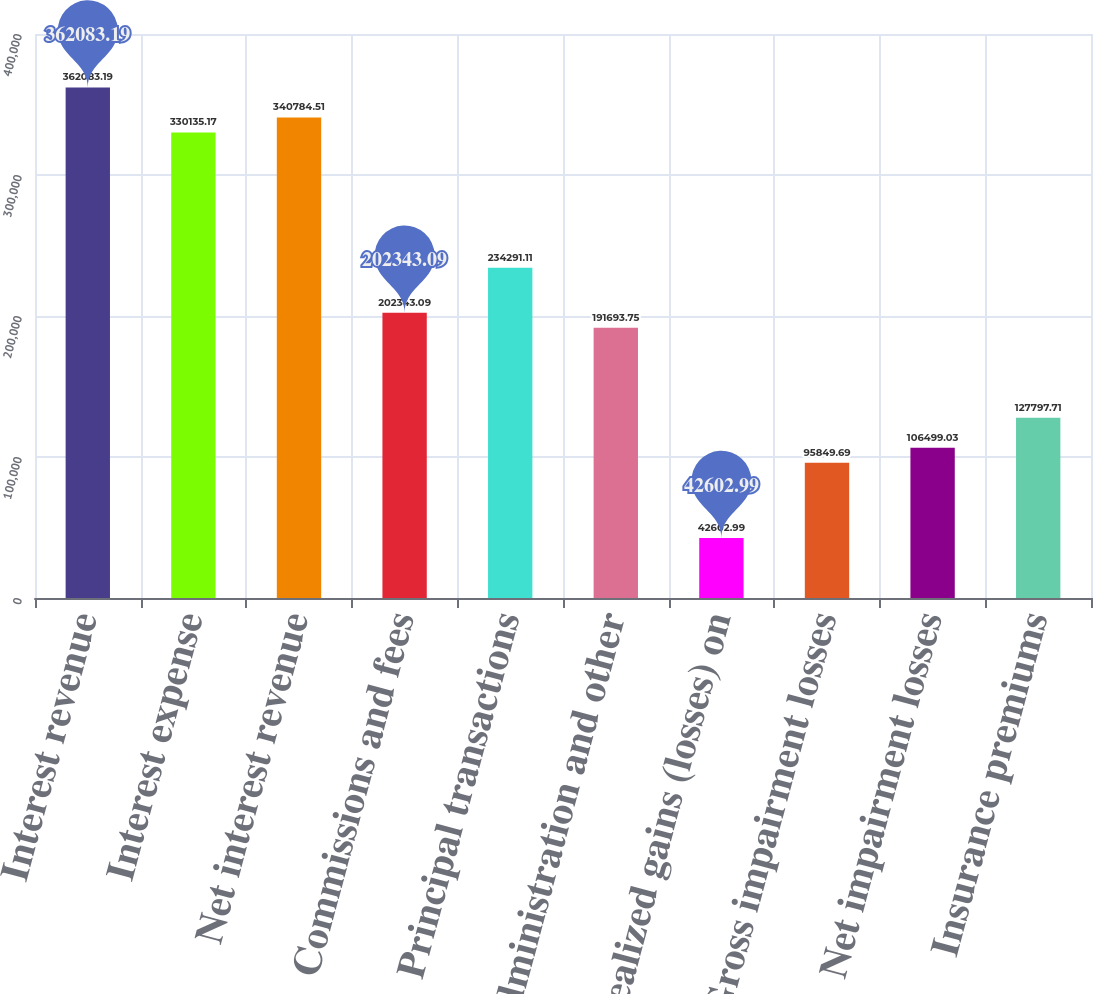<chart> <loc_0><loc_0><loc_500><loc_500><bar_chart><fcel>Interest revenue<fcel>Interest expense<fcel>Net interest revenue<fcel>Commissions and fees<fcel>Principal transactions<fcel>Administration and other<fcel>Realized gains (losses) on<fcel>Gross impairment losses<fcel>Net impairment losses<fcel>Insurance premiums<nl><fcel>362083<fcel>330135<fcel>340785<fcel>202343<fcel>234291<fcel>191694<fcel>42603<fcel>95849.7<fcel>106499<fcel>127798<nl></chart> 